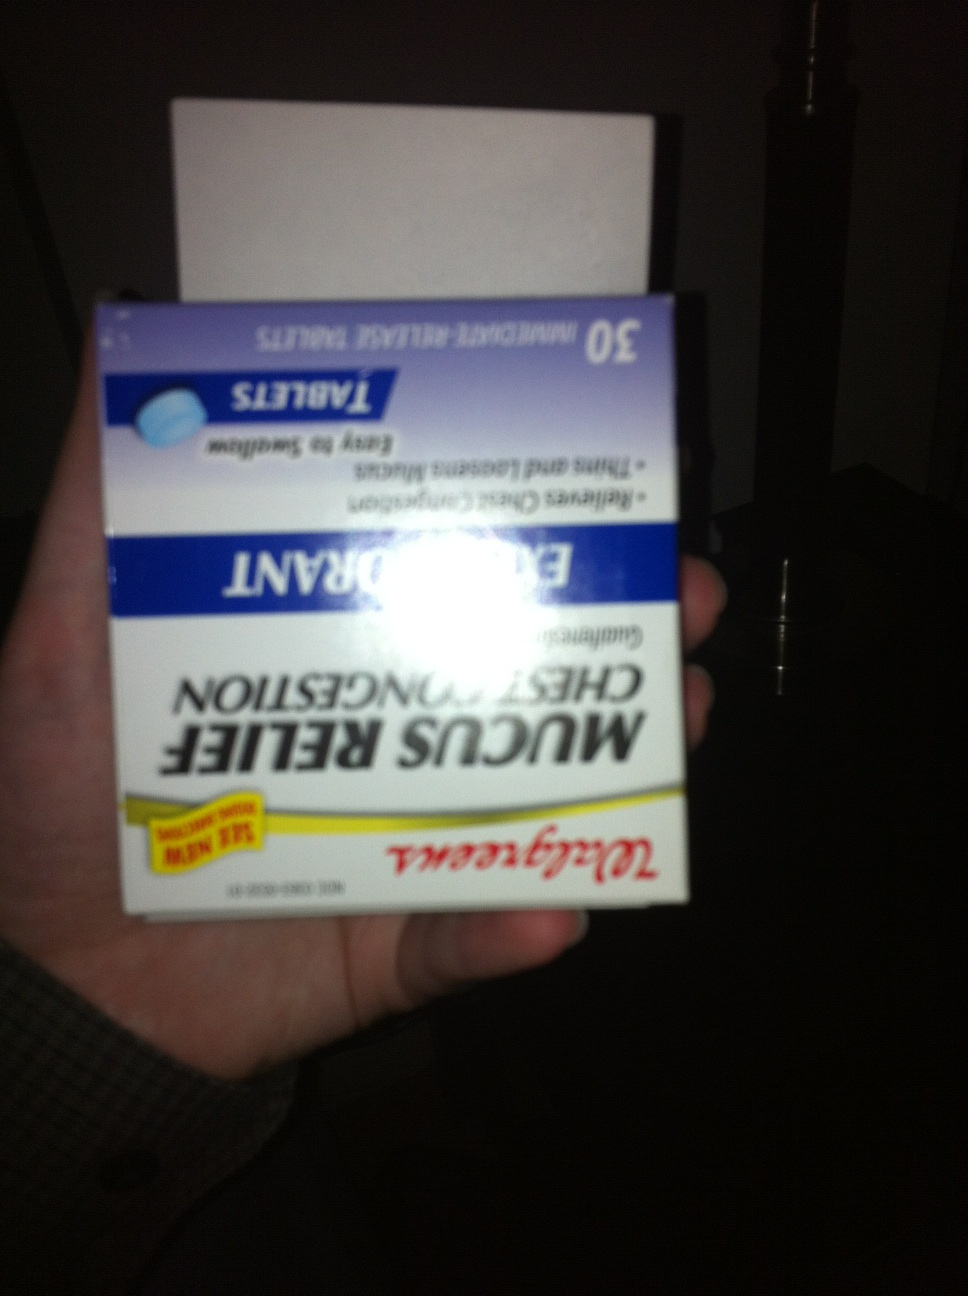Imagine if this product could talk. What would it say about its purpose? Hello! I'm Walgreens Mucus Relief Chest Congestion, and I'm here to help you breathe easier. My formula contains Guaifenesin, which works to loosen and thin stubborn mucus that's blocking your airways. With each tablet, I'm doing my best to clear out congestion, making it simpler for you to cough up and expel mucus. Remember to follow the dosage and drink lots of fluids so I can work my magic effectively. Let's clear those airways together! 